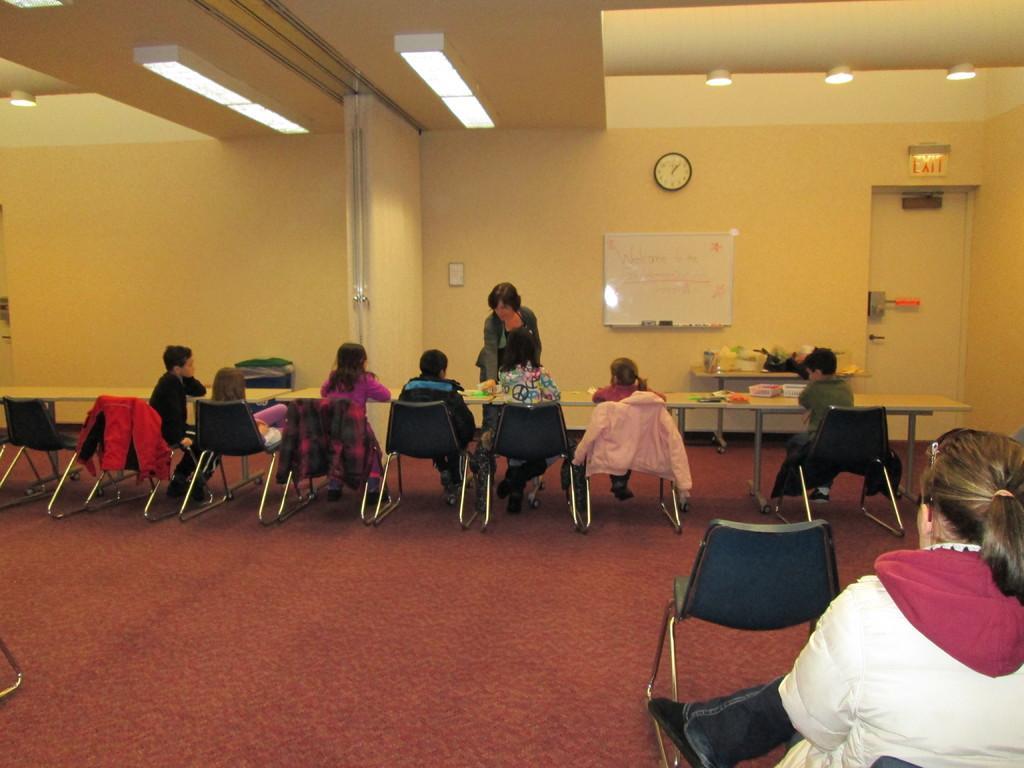Please provide a concise description of this image. There is one person sitting on a chair at the bottom right corner of this image and there is a chair beside to this person. There are some persons sitting on the chairs and there are some tables in the middle of this image. There is a wall in the background. There is a white color board and a wall clock attached on this wall. There are some lights arranged at the top of this image. There is a floor at the bottom of this image. 